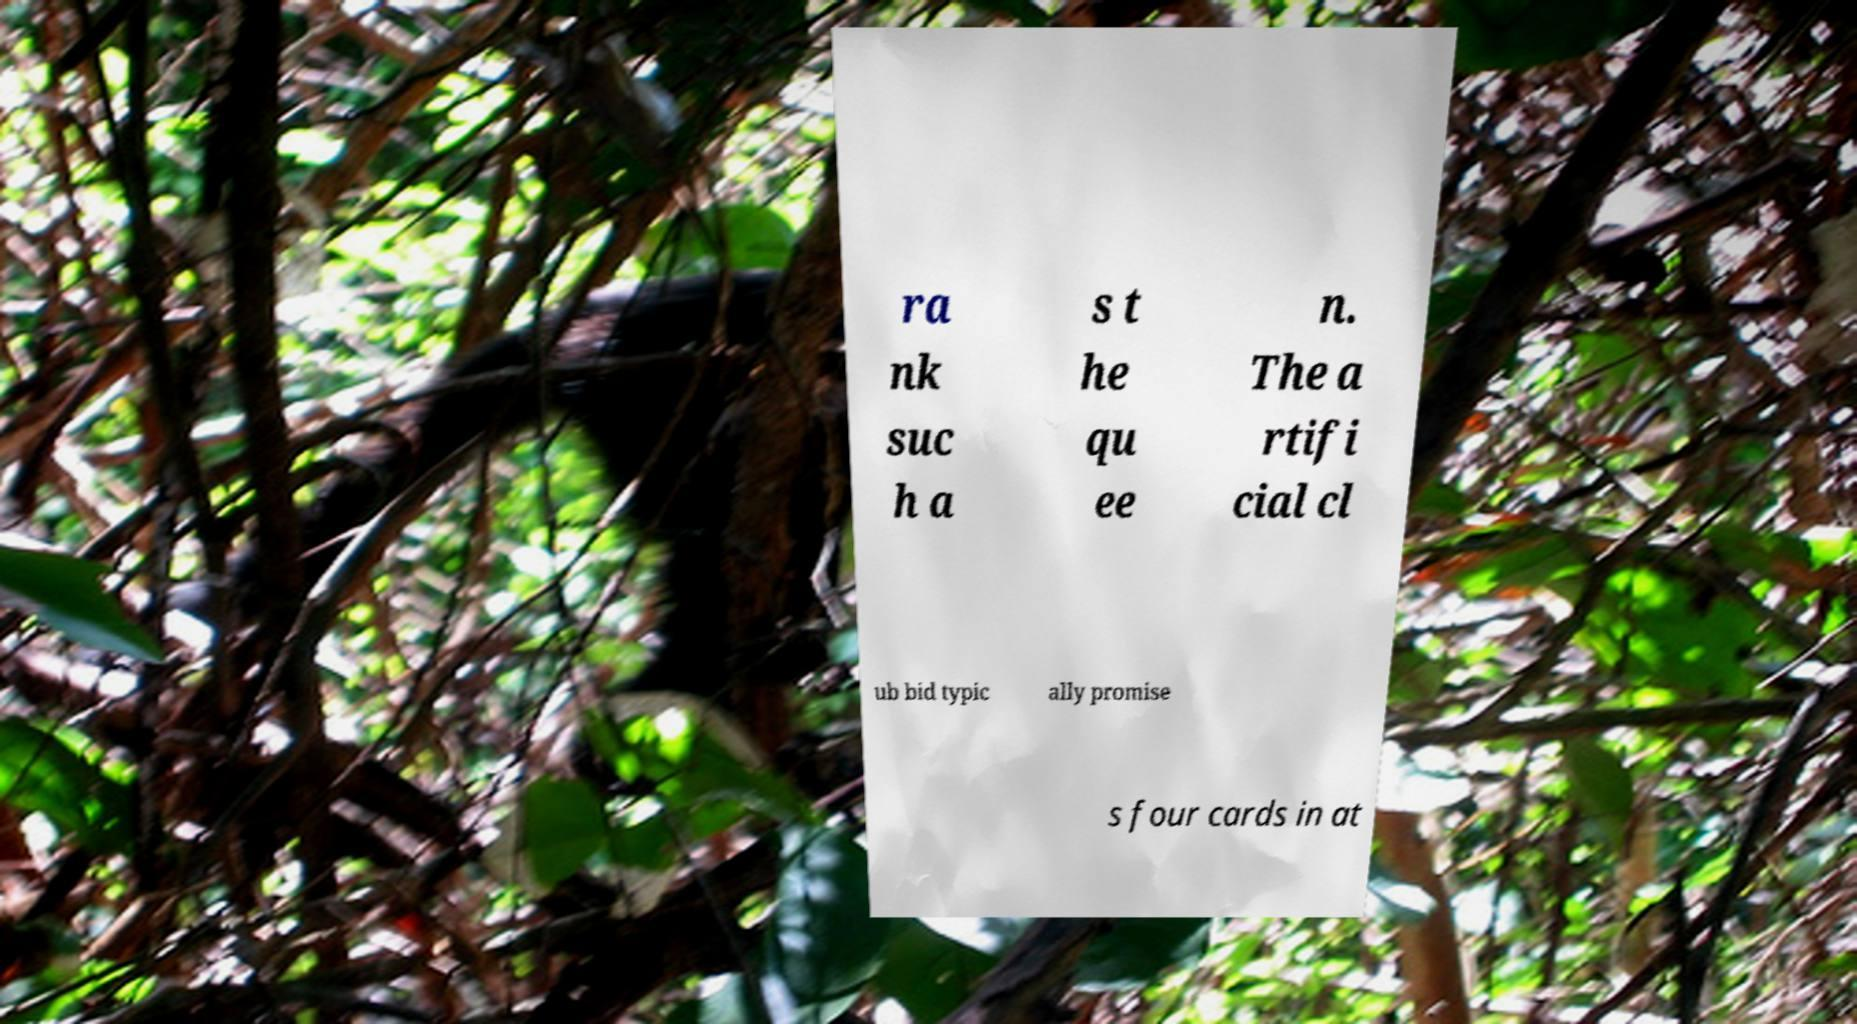Could you extract and type out the text from this image? ra nk suc h a s t he qu ee n. The a rtifi cial cl ub bid typic ally promise s four cards in at 